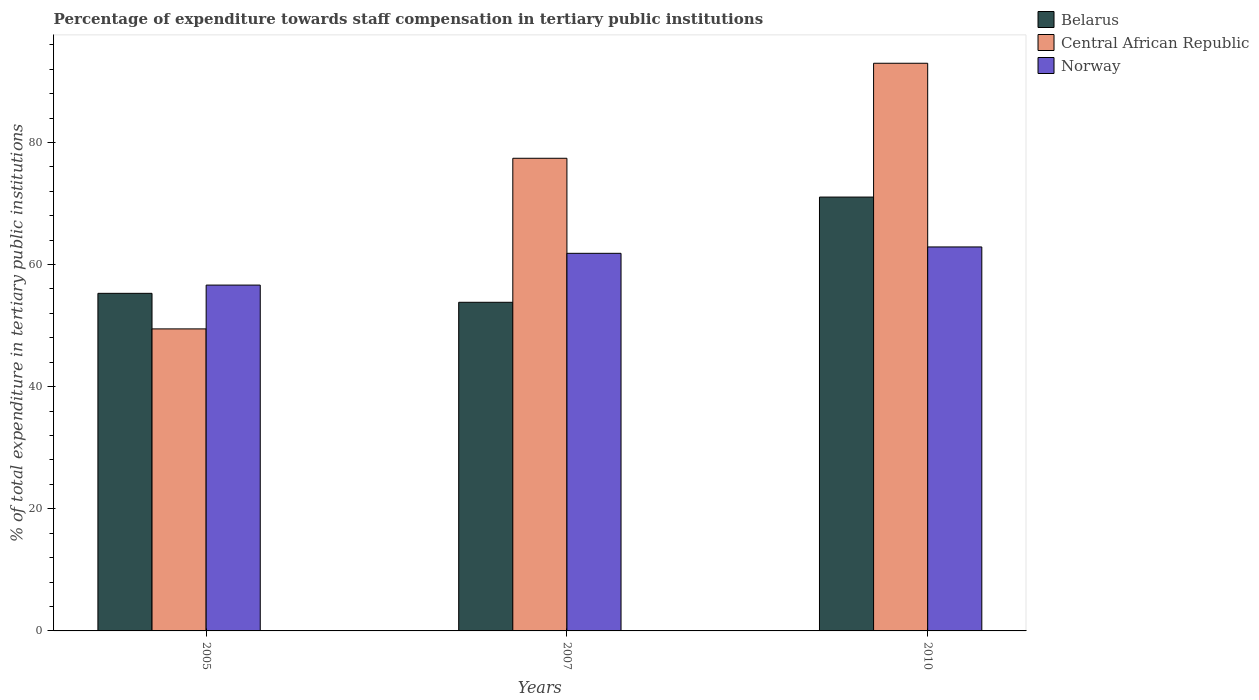How many different coloured bars are there?
Offer a very short reply. 3. Are the number of bars per tick equal to the number of legend labels?
Your answer should be compact. Yes. How many bars are there on the 3rd tick from the right?
Your answer should be very brief. 3. In how many cases, is the number of bars for a given year not equal to the number of legend labels?
Offer a terse response. 0. What is the percentage of expenditure towards staff compensation in Belarus in 2005?
Your answer should be very brief. 55.29. Across all years, what is the maximum percentage of expenditure towards staff compensation in Belarus?
Keep it short and to the point. 71.05. Across all years, what is the minimum percentage of expenditure towards staff compensation in Central African Republic?
Provide a short and direct response. 49.46. In which year was the percentage of expenditure towards staff compensation in Norway maximum?
Provide a short and direct response. 2010. What is the total percentage of expenditure towards staff compensation in Central African Republic in the graph?
Keep it short and to the point. 219.84. What is the difference between the percentage of expenditure towards staff compensation in Belarus in 2005 and that in 2007?
Give a very brief answer. 1.47. What is the difference between the percentage of expenditure towards staff compensation in Central African Republic in 2007 and the percentage of expenditure towards staff compensation in Norway in 2005?
Keep it short and to the point. 20.77. What is the average percentage of expenditure towards staff compensation in Central African Republic per year?
Provide a succinct answer. 73.28. In the year 2010, what is the difference between the percentage of expenditure towards staff compensation in Norway and percentage of expenditure towards staff compensation in Central African Republic?
Offer a very short reply. -30.08. What is the ratio of the percentage of expenditure towards staff compensation in Belarus in 2007 to that in 2010?
Make the answer very short. 0.76. Is the percentage of expenditure towards staff compensation in Central African Republic in 2005 less than that in 2010?
Your answer should be compact. Yes. Is the difference between the percentage of expenditure towards staff compensation in Norway in 2007 and 2010 greater than the difference between the percentage of expenditure towards staff compensation in Central African Republic in 2007 and 2010?
Offer a very short reply. Yes. What is the difference between the highest and the second highest percentage of expenditure towards staff compensation in Norway?
Offer a very short reply. 1.04. What is the difference between the highest and the lowest percentage of expenditure towards staff compensation in Norway?
Ensure brevity in your answer.  6.25. What does the 2nd bar from the left in 2010 represents?
Your answer should be compact. Central African Republic. What does the 1st bar from the right in 2005 represents?
Offer a terse response. Norway. Is it the case that in every year, the sum of the percentage of expenditure towards staff compensation in Belarus and percentage of expenditure towards staff compensation in Norway is greater than the percentage of expenditure towards staff compensation in Central African Republic?
Your answer should be very brief. Yes. How many bars are there?
Keep it short and to the point. 9. How many years are there in the graph?
Give a very brief answer. 3. What is the difference between two consecutive major ticks on the Y-axis?
Your response must be concise. 20. Are the values on the major ticks of Y-axis written in scientific E-notation?
Make the answer very short. No. Does the graph contain any zero values?
Your answer should be compact. No. Does the graph contain grids?
Give a very brief answer. No. Where does the legend appear in the graph?
Offer a very short reply. Top right. How many legend labels are there?
Provide a short and direct response. 3. What is the title of the graph?
Keep it short and to the point. Percentage of expenditure towards staff compensation in tertiary public institutions. Does "Upper middle income" appear as one of the legend labels in the graph?
Your response must be concise. No. What is the label or title of the X-axis?
Your response must be concise. Years. What is the label or title of the Y-axis?
Offer a very short reply. % of total expenditure in tertiary public institutions. What is the % of total expenditure in tertiary public institutions in Belarus in 2005?
Ensure brevity in your answer.  55.29. What is the % of total expenditure in tertiary public institutions in Central African Republic in 2005?
Provide a succinct answer. 49.46. What is the % of total expenditure in tertiary public institutions in Norway in 2005?
Your answer should be compact. 56.64. What is the % of total expenditure in tertiary public institutions in Belarus in 2007?
Keep it short and to the point. 53.82. What is the % of total expenditure in tertiary public institutions of Central African Republic in 2007?
Ensure brevity in your answer.  77.41. What is the % of total expenditure in tertiary public institutions of Norway in 2007?
Keep it short and to the point. 61.84. What is the % of total expenditure in tertiary public institutions of Belarus in 2010?
Offer a very short reply. 71.05. What is the % of total expenditure in tertiary public institutions of Central African Republic in 2010?
Your answer should be very brief. 92.97. What is the % of total expenditure in tertiary public institutions in Norway in 2010?
Your answer should be very brief. 62.89. Across all years, what is the maximum % of total expenditure in tertiary public institutions in Belarus?
Offer a very short reply. 71.05. Across all years, what is the maximum % of total expenditure in tertiary public institutions in Central African Republic?
Your answer should be compact. 92.97. Across all years, what is the maximum % of total expenditure in tertiary public institutions in Norway?
Your answer should be very brief. 62.89. Across all years, what is the minimum % of total expenditure in tertiary public institutions in Belarus?
Give a very brief answer. 53.82. Across all years, what is the minimum % of total expenditure in tertiary public institutions in Central African Republic?
Keep it short and to the point. 49.46. Across all years, what is the minimum % of total expenditure in tertiary public institutions in Norway?
Provide a succinct answer. 56.64. What is the total % of total expenditure in tertiary public institutions in Belarus in the graph?
Offer a terse response. 180.16. What is the total % of total expenditure in tertiary public institutions of Central African Republic in the graph?
Your answer should be compact. 219.84. What is the total % of total expenditure in tertiary public institutions in Norway in the graph?
Keep it short and to the point. 181.37. What is the difference between the % of total expenditure in tertiary public institutions of Belarus in 2005 and that in 2007?
Provide a succinct answer. 1.47. What is the difference between the % of total expenditure in tertiary public institutions of Central African Republic in 2005 and that in 2007?
Ensure brevity in your answer.  -27.94. What is the difference between the % of total expenditure in tertiary public institutions of Norway in 2005 and that in 2007?
Make the answer very short. -5.2. What is the difference between the % of total expenditure in tertiary public institutions of Belarus in 2005 and that in 2010?
Give a very brief answer. -15.77. What is the difference between the % of total expenditure in tertiary public institutions of Central African Republic in 2005 and that in 2010?
Offer a terse response. -43.51. What is the difference between the % of total expenditure in tertiary public institutions in Norway in 2005 and that in 2010?
Keep it short and to the point. -6.25. What is the difference between the % of total expenditure in tertiary public institutions in Belarus in 2007 and that in 2010?
Your response must be concise. -17.23. What is the difference between the % of total expenditure in tertiary public institutions of Central African Republic in 2007 and that in 2010?
Provide a short and direct response. -15.56. What is the difference between the % of total expenditure in tertiary public institutions in Norway in 2007 and that in 2010?
Provide a succinct answer. -1.04. What is the difference between the % of total expenditure in tertiary public institutions of Belarus in 2005 and the % of total expenditure in tertiary public institutions of Central African Republic in 2007?
Make the answer very short. -22.12. What is the difference between the % of total expenditure in tertiary public institutions of Belarus in 2005 and the % of total expenditure in tertiary public institutions of Norway in 2007?
Offer a very short reply. -6.55. What is the difference between the % of total expenditure in tertiary public institutions of Central African Republic in 2005 and the % of total expenditure in tertiary public institutions of Norway in 2007?
Ensure brevity in your answer.  -12.38. What is the difference between the % of total expenditure in tertiary public institutions in Belarus in 2005 and the % of total expenditure in tertiary public institutions in Central African Republic in 2010?
Give a very brief answer. -37.68. What is the difference between the % of total expenditure in tertiary public institutions of Belarus in 2005 and the % of total expenditure in tertiary public institutions of Norway in 2010?
Ensure brevity in your answer.  -7.6. What is the difference between the % of total expenditure in tertiary public institutions of Central African Republic in 2005 and the % of total expenditure in tertiary public institutions of Norway in 2010?
Keep it short and to the point. -13.42. What is the difference between the % of total expenditure in tertiary public institutions in Belarus in 2007 and the % of total expenditure in tertiary public institutions in Central African Republic in 2010?
Ensure brevity in your answer.  -39.15. What is the difference between the % of total expenditure in tertiary public institutions in Belarus in 2007 and the % of total expenditure in tertiary public institutions in Norway in 2010?
Your answer should be compact. -9.06. What is the difference between the % of total expenditure in tertiary public institutions in Central African Republic in 2007 and the % of total expenditure in tertiary public institutions in Norway in 2010?
Your response must be concise. 14.52. What is the average % of total expenditure in tertiary public institutions of Belarus per year?
Provide a short and direct response. 60.05. What is the average % of total expenditure in tertiary public institutions of Central African Republic per year?
Make the answer very short. 73.28. What is the average % of total expenditure in tertiary public institutions in Norway per year?
Give a very brief answer. 60.46. In the year 2005, what is the difference between the % of total expenditure in tertiary public institutions in Belarus and % of total expenditure in tertiary public institutions in Central African Republic?
Your answer should be compact. 5.83. In the year 2005, what is the difference between the % of total expenditure in tertiary public institutions in Belarus and % of total expenditure in tertiary public institutions in Norway?
Keep it short and to the point. -1.35. In the year 2005, what is the difference between the % of total expenditure in tertiary public institutions in Central African Republic and % of total expenditure in tertiary public institutions in Norway?
Give a very brief answer. -7.18. In the year 2007, what is the difference between the % of total expenditure in tertiary public institutions in Belarus and % of total expenditure in tertiary public institutions in Central African Republic?
Offer a terse response. -23.59. In the year 2007, what is the difference between the % of total expenditure in tertiary public institutions of Belarus and % of total expenditure in tertiary public institutions of Norway?
Your response must be concise. -8.02. In the year 2007, what is the difference between the % of total expenditure in tertiary public institutions of Central African Republic and % of total expenditure in tertiary public institutions of Norway?
Provide a succinct answer. 15.57. In the year 2010, what is the difference between the % of total expenditure in tertiary public institutions of Belarus and % of total expenditure in tertiary public institutions of Central African Republic?
Your answer should be compact. -21.92. In the year 2010, what is the difference between the % of total expenditure in tertiary public institutions of Belarus and % of total expenditure in tertiary public institutions of Norway?
Keep it short and to the point. 8.17. In the year 2010, what is the difference between the % of total expenditure in tertiary public institutions of Central African Republic and % of total expenditure in tertiary public institutions of Norway?
Keep it short and to the point. 30.08. What is the ratio of the % of total expenditure in tertiary public institutions of Belarus in 2005 to that in 2007?
Give a very brief answer. 1.03. What is the ratio of the % of total expenditure in tertiary public institutions of Central African Republic in 2005 to that in 2007?
Give a very brief answer. 0.64. What is the ratio of the % of total expenditure in tertiary public institutions in Norway in 2005 to that in 2007?
Ensure brevity in your answer.  0.92. What is the ratio of the % of total expenditure in tertiary public institutions of Belarus in 2005 to that in 2010?
Provide a succinct answer. 0.78. What is the ratio of the % of total expenditure in tertiary public institutions of Central African Republic in 2005 to that in 2010?
Provide a succinct answer. 0.53. What is the ratio of the % of total expenditure in tertiary public institutions of Norway in 2005 to that in 2010?
Keep it short and to the point. 0.9. What is the ratio of the % of total expenditure in tertiary public institutions in Belarus in 2007 to that in 2010?
Your answer should be very brief. 0.76. What is the ratio of the % of total expenditure in tertiary public institutions in Central African Republic in 2007 to that in 2010?
Ensure brevity in your answer.  0.83. What is the ratio of the % of total expenditure in tertiary public institutions of Norway in 2007 to that in 2010?
Provide a succinct answer. 0.98. What is the difference between the highest and the second highest % of total expenditure in tertiary public institutions in Belarus?
Offer a very short reply. 15.77. What is the difference between the highest and the second highest % of total expenditure in tertiary public institutions in Central African Republic?
Provide a succinct answer. 15.56. What is the difference between the highest and the second highest % of total expenditure in tertiary public institutions of Norway?
Your answer should be very brief. 1.04. What is the difference between the highest and the lowest % of total expenditure in tertiary public institutions of Belarus?
Your answer should be compact. 17.23. What is the difference between the highest and the lowest % of total expenditure in tertiary public institutions of Central African Republic?
Offer a terse response. 43.51. What is the difference between the highest and the lowest % of total expenditure in tertiary public institutions of Norway?
Provide a succinct answer. 6.25. 